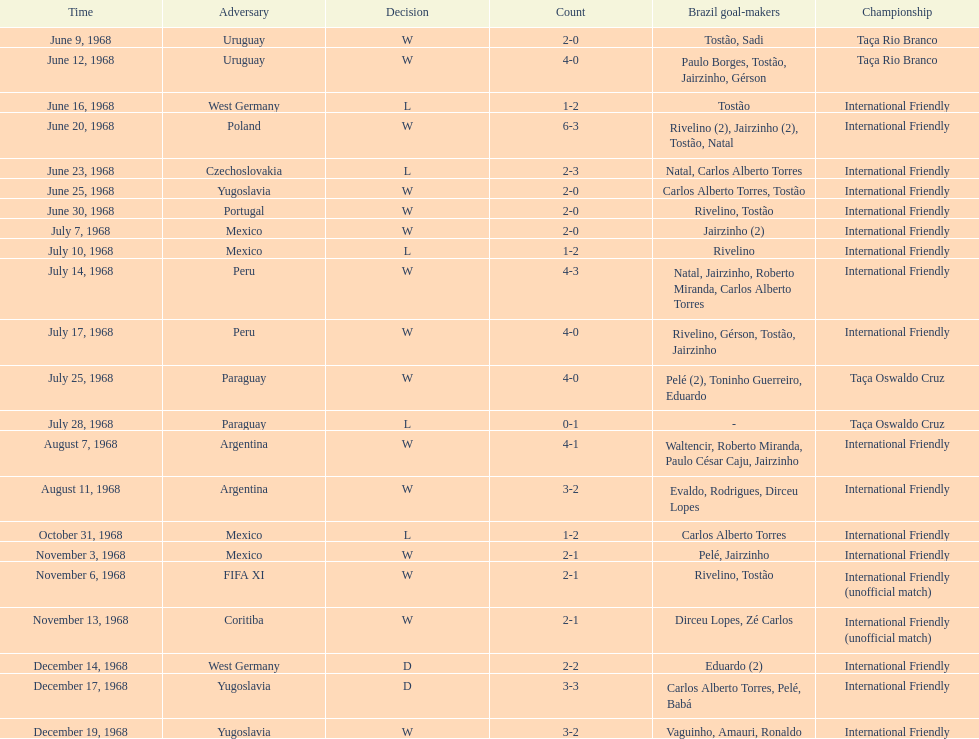Total number of wins 15. 